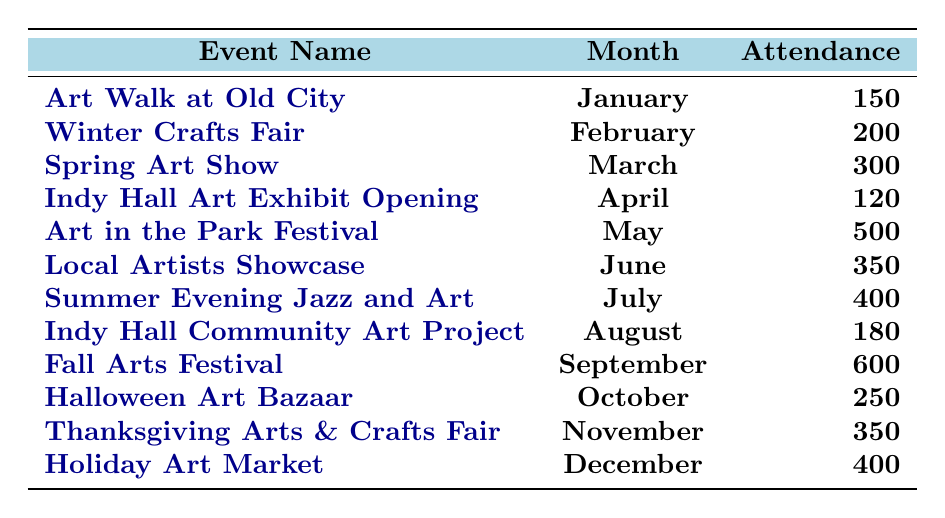What is the attendance for the "Art Walk at Old City"? The table shows that the attendance for the "Art Walk at Old City" in January 2023 is 150.
Answer: 150 Which event had the highest attendance? By examining the attendance figures in the table, the "Fall Arts Festival" in September had the highest attendance, with 600 people.
Answer: 600 What is the total attendance for the events held in the summer months (June, July, August)? The summer months' events are "Local Artists Showcase" (350), "Summer Evening Jazz and Art" (400), and "Indy Hall Community Art Project" (180). The total is calculated as 350 + 400 + 180 = 930.
Answer: 930 Is the attendance for the "Halloween Art Bazaar" greater than 200? Looking at the table, the attendance for the "Halloween Art Bazaar" is 250, which is greater than 200.
Answer: Yes What was the average attendance for all events in 2023? To find the average, sum all the attendance numbers: 150 + 200 + 300 + 120 + 500 + 350 + 400 + 180 + 600 + 250 + 350 + 400 = 4,000. There are 12 events, so the average attendance is 4000/12 = 333.33.
Answer: 333.33 How many events had attendance figures above 300? From the table, the events with attendance above 300 are "Spring Art Show" (300), "Art in the Park Festival" (500), "Local Artists Showcase" (350), "Summer Evening Jazz and Art" (400), "Fall Arts Festival" (600), "Thanksgiving Arts & Crafts Fair" (350), and "Holiday Art Market" (400). Counting these, there are 6 such events.
Answer: 6 Which month had an event with the lowest attendance? Looking at the attendance numbers in the table, "Indy Hall Art Exhibit Opening" in April had the lowest attendance of 120.
Answer: 120 What is the difference in attendance between the highest and lowest attended events? The highest attendance is for the "Fall Arts Festival" (600), and the lowest is for "Indy Hall Art Exhibit Opening" (120). The difference is 600 - 120 = 480.
Answer: 480 How many events took place in the fall season (September to November)? The events in the fall are "Fall Arts Festival" (September), "Halloween Art Bazaar" (October), and "Thanksgiving Arts & Crafts Fair" (November). There are a total of 3 events in the fall.
Answer: 3 Was the attendance for the "Art in the Park Festival" higher than the attendance for "Spring Art Show"? The attendance for the "Art in the Park Festival" is 500, while for the "Spring Art Show" it is 300. Since 500 > 300, the attendance for the first event is higher.
Answer: Yes 